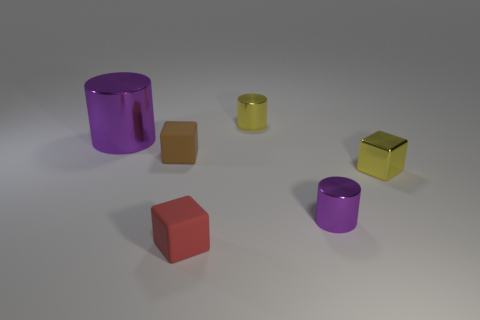Do the red matte thing and the yellow shiny thing left of the small yellow cube have the same size?
Make the answer very short. Yes. What number of things are large cyan shiny cylinders or large metallic cylinders?
Keep it short and to the point. 1. What number of other cylinders have the same color as the large cylinder?
Your response must be concise. 1. What is the shape of the brown object that is the same size as the red object?
Your answer should be very brief. Cube. Is there a tiny gray matte thing that has the same shape as the large shiny object?
Provide a short and direct response. No. What number of small red balls have the same material as the brown object?
Provide a succinct answer. 0. Is the yellow thing in front of the big metal cylinder made of the same material as the small yellow cylinder?
Give a very brief answer. Yes. Is the number of big purple things right of the small red matte thing greater than the number of tiny yellow cylinders that are to the left of the tiny yellow metallic cylinder?
Make the answer very short. No. There is a brown thing that is the same size as the red block; what is its material?
Offer a very short reply. Rubber. How many other objects are the same material as the yellow cube?
Offer a terse response. 3. 